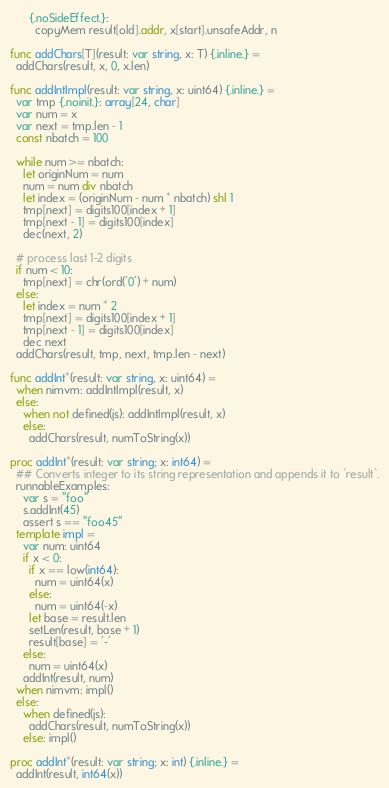Convert code to text. <code><loc_0><loc_0><loc_500><loc_500><_Nim_>      {.noSideEffect.}:
        copyMem result[old].addr, x[start].unsafeAddr, n

func addChars[T](result: var string, x: T) {.inline.} =
  addChars(result, x, 0, x.len)

func addIntImpl(result: var string, x: uint64) {.inline.} =
  var tmp {.noinit.}: array[24, char]
  var num = x
  var next = tmp.len - 1
  const nbatch = 100

  while num >= nbatch:
    let originNum = num
    num = num div nbatch
    let index = (originNum - num * nbatch) shl 1
    tmp[next] = digits100[index + 1]
    tmp[next - 1] = digits100[index]
    dec(next, 2)

  # process last 1-2 digits
  if num < 10:
    tmp[next] = chr(ord('0') + num)
  else:
    let index = num * 2
    tmp[next] = digits100[index + 1]
    tmp[next - 1] = digits100[index]
    dec next
  addChars(result, tmp, next, tmp.len - next)

func addInt*(result: var string, x: uint64) =
  when nimvm: addIntImpl(result, x)
  else:
    when not defined(js): addIntImpl(result, x)
    else:
      addChars(result, numToString(x))

proc addInt*(result: var string; x: int64) =
  ## Converts integer to its string representation and appends it to `result`.
  runnableExamples:
    var s = "foo"
    s.addInt(45)
    assert s == "foo45"
  template impl =
    var num: uint64
    if x < 0:
      if x == low(int64):
        num = uint64(x)
      else:
        num = uint64(-x)
      let base = result.len
      setLen(result, base + 1)
      result[base] = '-'
    else:
      num = uint64(x)
    addInt(result, num)
  when nimvm: impl()
  else:
    when defined(js):
      addChars(result, numToString(x))
    else: impl()

proc addInt*(result: var string; x: int) {.inline.} =
  addInt(result, int64(x))
</code> 